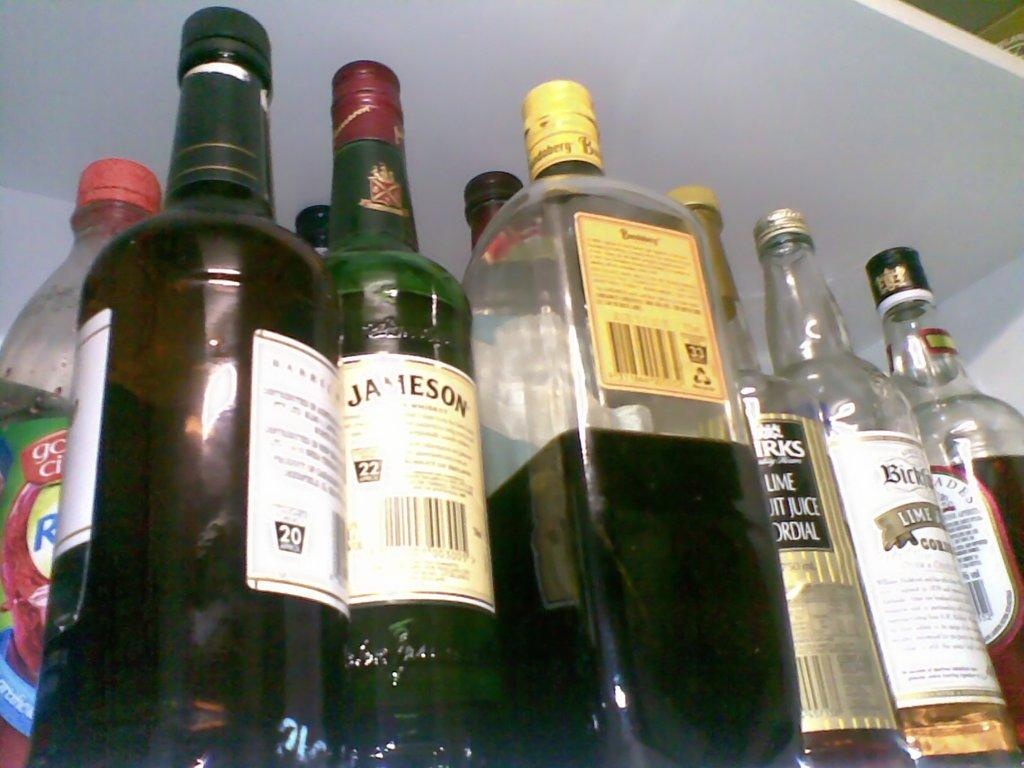<image>
Share a concise interpretation of the image provided. Various bottles are in a cabinet including one for Jameson. 